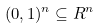<formula> <loc_0><loc_0><loc_500><loc_500>( 0 , 1 ) ^ { n } \subseteq R ^ { n }</formula> 